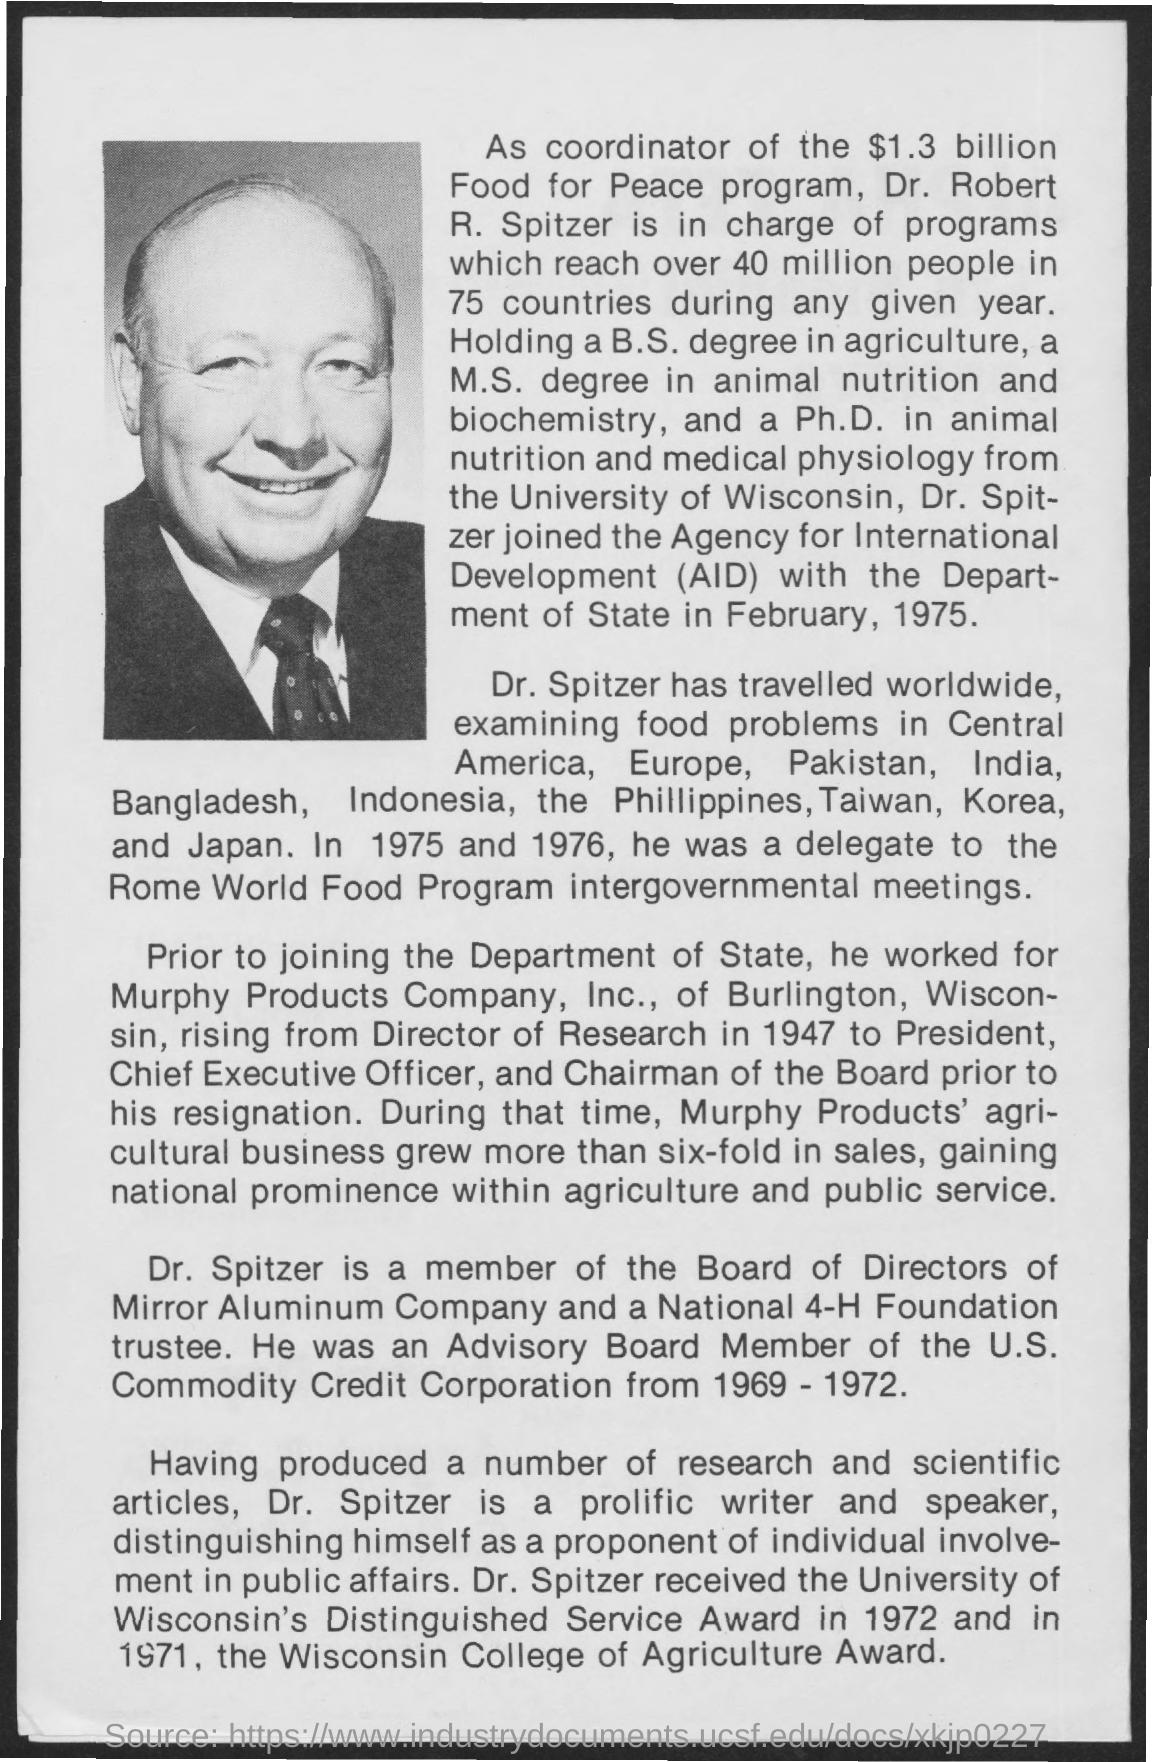Indicate a few pertinent items in this graphic. The full form of AID is Agency for International Development. Dr. Spitzer joined the Agency for International Development (AID) of the Department of State in February 1975. Dr. Spitzer was a delegate to the Rome World Food Program intergovernmental meetings in both 1975 and 1976. Dr. Spitzer served as a member of the Advisory Board for the U.S. Commodity Corporation from 1969 to 1972. 